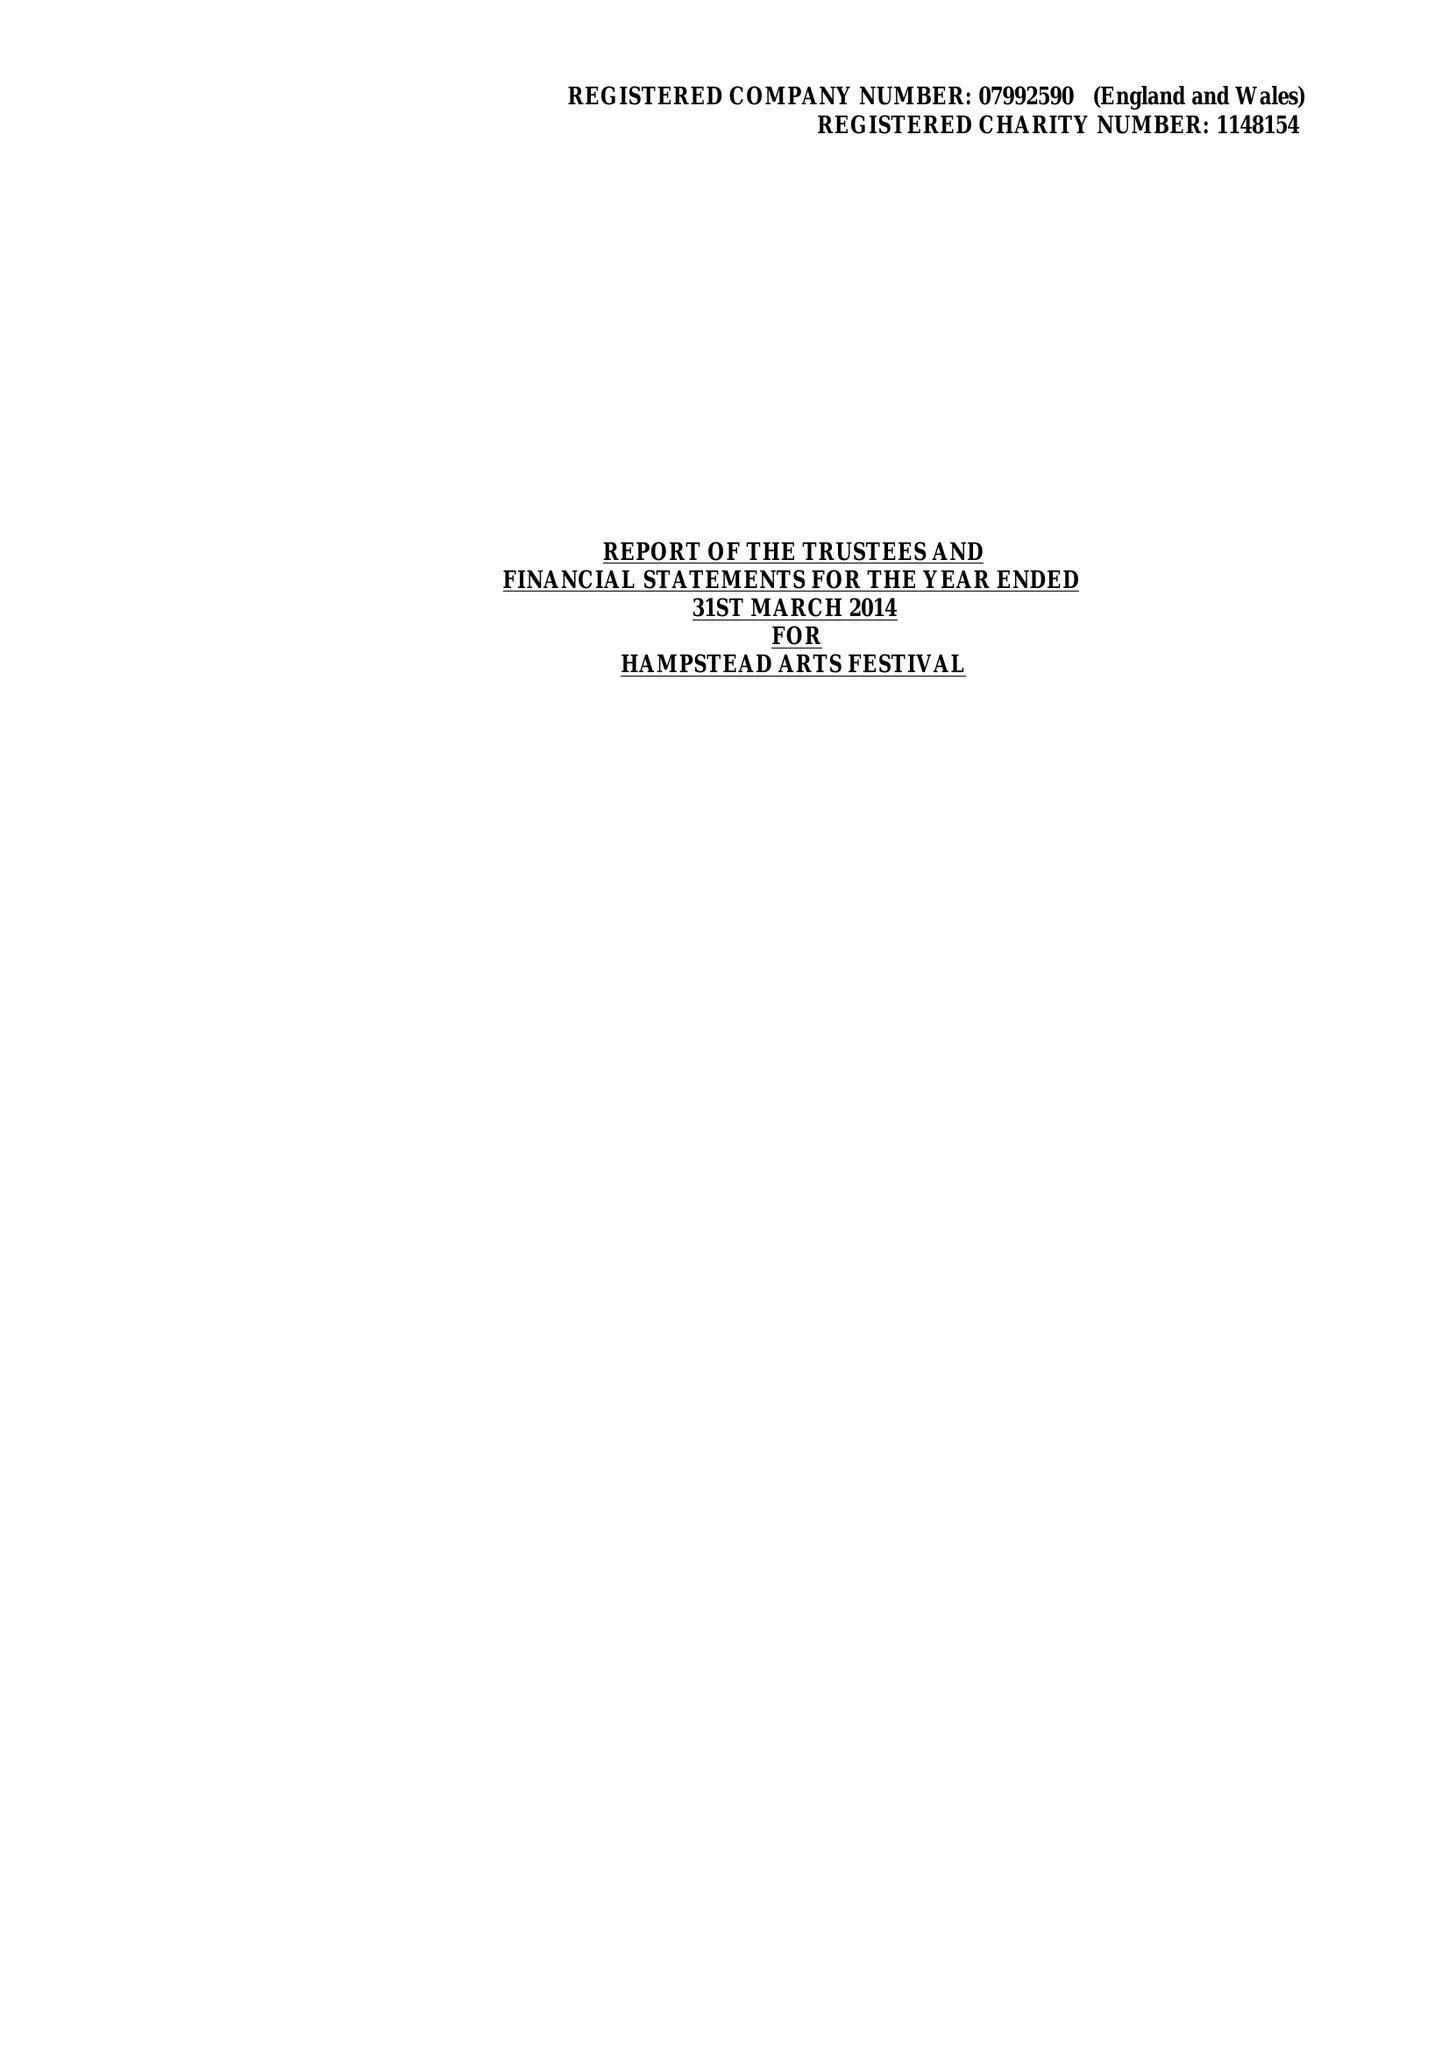What is the value for the address__street_line?
Answer the question using a single word or phrase. 31/33 COLLEGE ROAD 